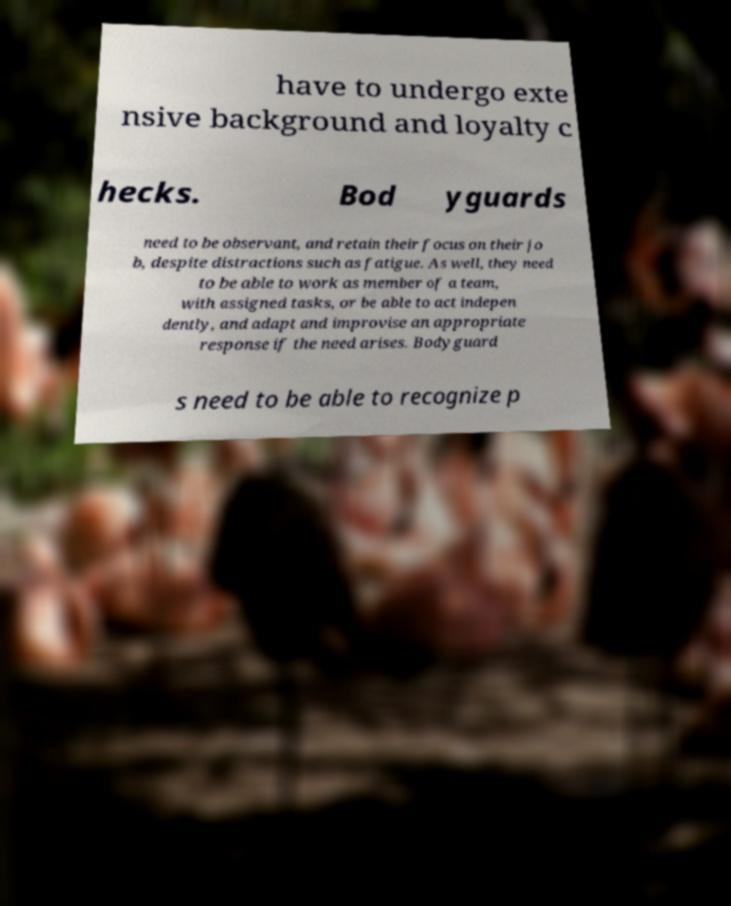What messages or text are displayed in this image? I need them in a readable, typed format. have to undergo exte nsive background and loyalty c hecks. Bod yguards need to be observant, and retain their focus on their jo b, despite distractions such as fatigue. As well, they need to be able to work as member of a team, with assigned tasks, or be able to act indepen dently, and adapt and improvise an appropriate response if the need arises. Bodyguard s need to be able to recognize p 